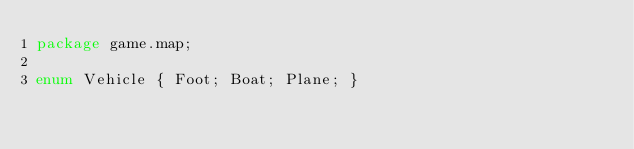Convert code to text. <code><loc_0><loc_0><loc_500><loc_500><_Haxe_>package game.map;

enum Vehicle { Foot; Boat; Plane; }
</code> 